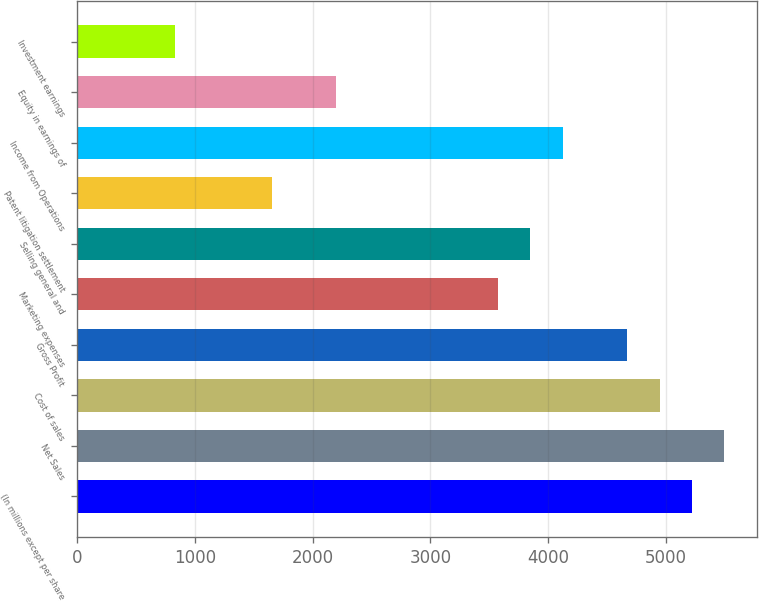Convert chart to OTSL. <chart><loc_0><loc_0><loc_500><loc_500><bar_chart><fcel>(In millions except per share<fcel>Net Sales<fcel>Cost of sales<fcel>Gross Profit<fcel>Marketing expenses<fcel>Selling general and<fcel>Patent litigation settlement<fcel>Income from Operations<fcel>Equity in earnings of<fcel>Investment earnings<nl><fcel>5223.32<fcel>5498.2<fcel>4948.44<fcel>4673.55<fcel>3574<fcel>3848.89<fcel>1649.78<fcel>4123.77<fcel>2199.55<fcel>825.12<nl></chart> 